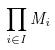Convert formula to latex. <formula><loc_0><loc_0><loc_500><loc_500>\prod _ { i \in I } M _ { i }</formula> 